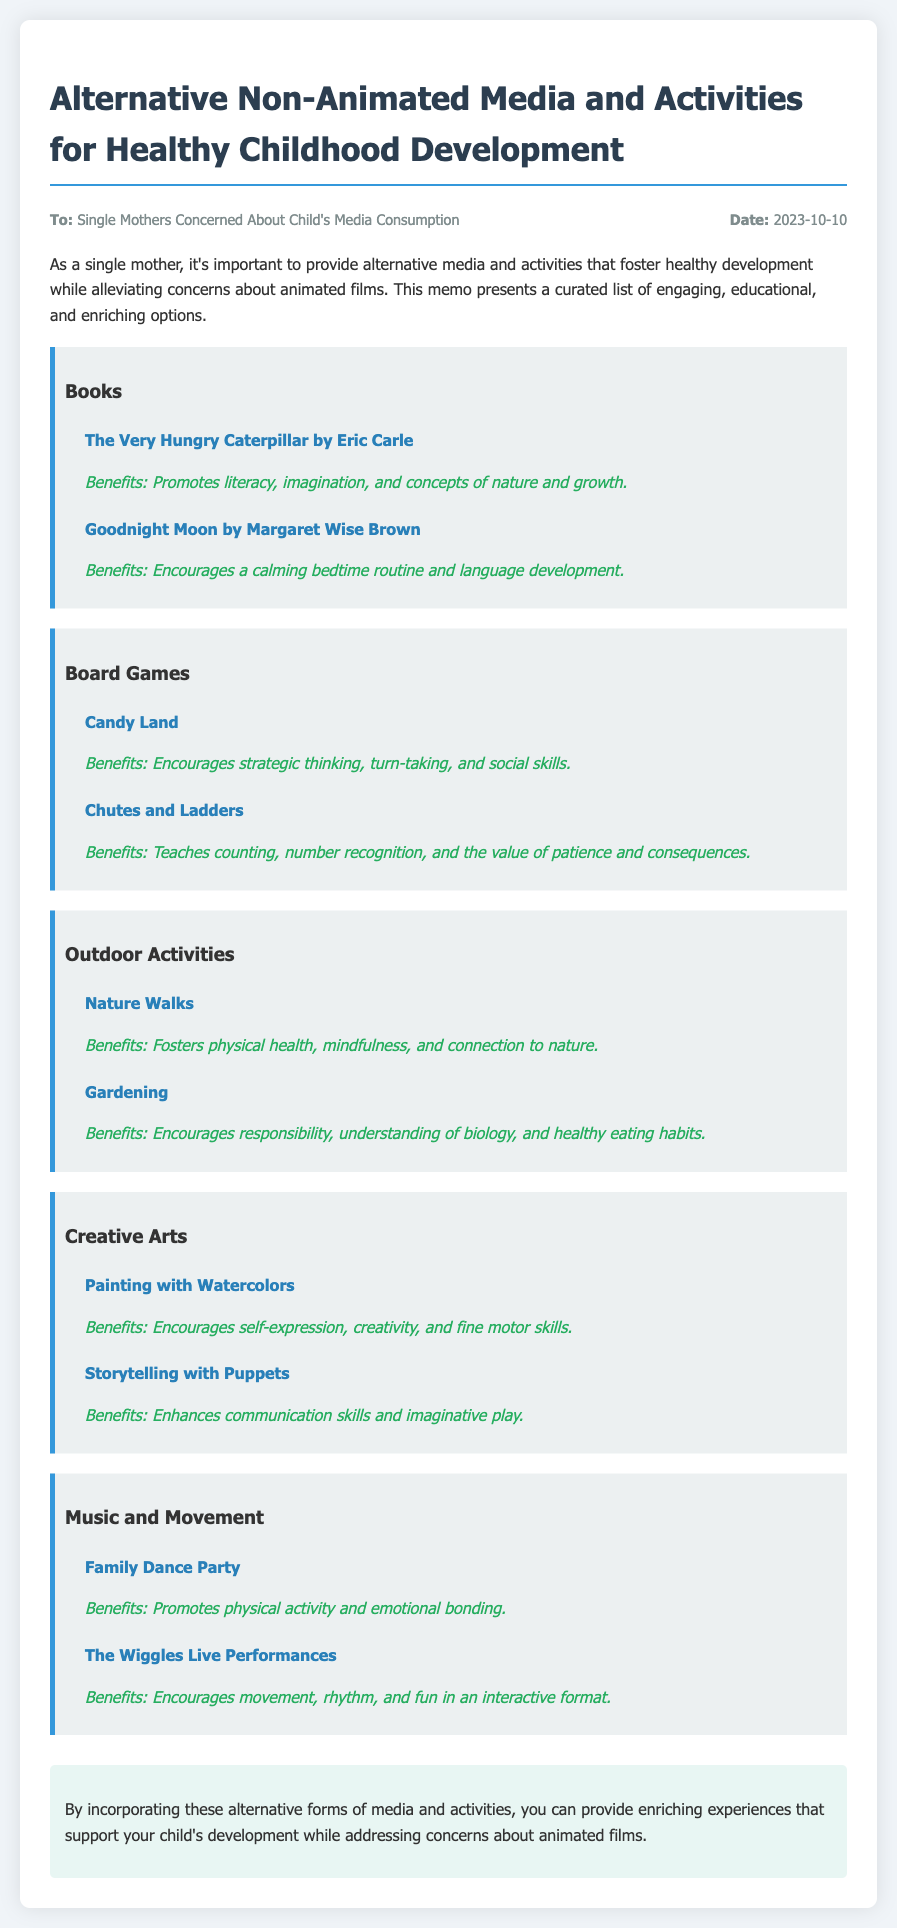What are the two book titles mentioned? The document lists two book titles: "The Very Hungry Caterpillar" and "Goodnight Moon."
Answer: "The Very Hungry Caterpillar, Goodnight Moon" What benefits does "Candy Land" provide? The document states that "Candy Land" encourages strategic thinking, turn-taking, and social skills.
Answer: Strategic thinking, turn-taking, social skills What outdoor activity is suggested for fostering mindfulness? According to the document, "Nature Walks" promote mindfulness along with physical health and connection to nature.
Answer: Nature Walks How many categories of activities are listed in the memo? The memo outlines five categories: Books, Board Games, Outdoor Activities, Creative Arts, and Music and Movement.
Answer: Five What is the benefit of "Painting with Watercolors"? The document mentions that painting with watercolors encourages self-expression, creativity, and fine motor skills.
Answer: Self-expression, creativity, fine motor skills What type of document is this? The format and content indicate that this is a memo aimed at single mothers concerned about their child's media consumption.
Answer: Memo 